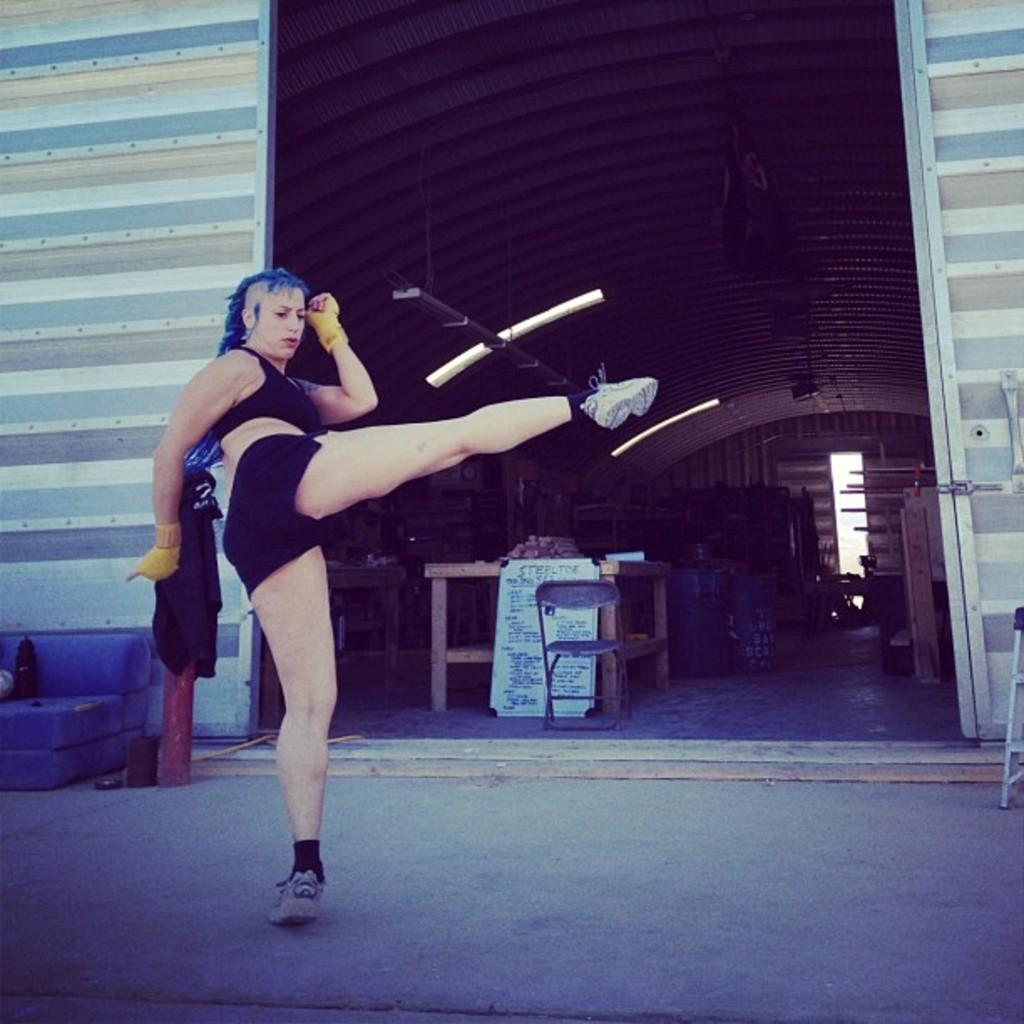What is the setting of the image? The image shows the inside view of a shed. Is there anyone present in the shed? Yes, there is a person in the shed. What type of furniture is in the shed? There is a chair in the shed. What material are the objects in the shed made of? There are wooden objects in the shed. How is the shed illuminated? There are lights in the shed. What is the level of wealth of the person in the shed? The image does not provide any information about the person's wealth, so it cannot be determined. 